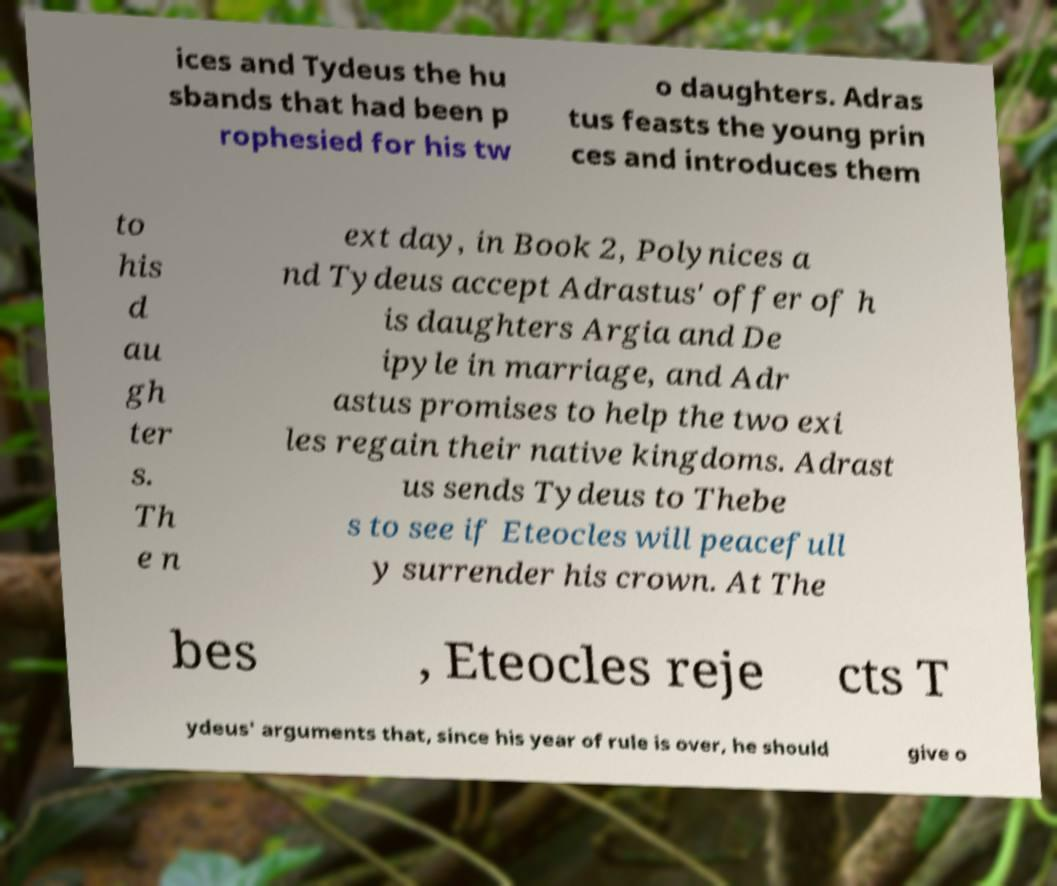What messages or text are displayed in this image? I need them in a readable, typed format. ices and Tydeus the hu sbands that had been p rophesied for his tw o daughters. Adras tus feasts the young prin ces and introduces them to his d au gh ter s. Th e n ext day, in Book 2, Polynices a nd Tydeus accept Adrastus' offer of h is daughters Argia and De ipyle in marriage, and Adr astus promises to help the two exi les regain their native kingdoms. Adrast us sends Tydeus to Thebe s to see if Eteocles will peacefull y surrender his crown. At The bes , Eteocles reje cts T ydeus' arguments that, since his year of rule is over, he should give o 